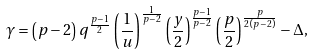<formula> <loc_0><loc_0><loc_500><loc_500>\gamma = \left ( p - 2 \right ) q ^ { \frac { p - 1 } { 2 } } \left ( \frac { 1 } { u } \right ) ^ { \frac { 1 } { p - 2 } } \left ( \frac { y } { 2 } \right ) ^ { \frac { p - 1 } { p - 2 } } \left ( \frac { p } { 2 } \right ) ^ { \frac { p } { 2 \left ( p - 2 \right ) } } - \Delta ,</formula> 